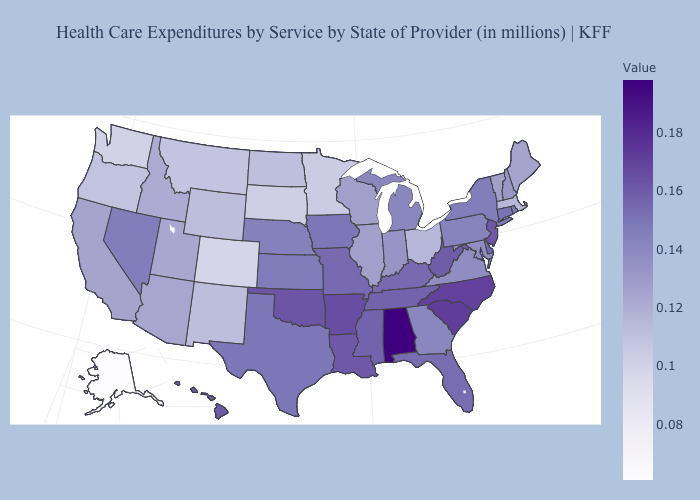Is the legend a continuous bar?
Answer briefly. Yes. Among the states that border Michigan , does Ohio have the lowest value?
Short answer required. Yes. Among the states that border Virginia , does Maryland have the lowest value?
Write a very short answer. Yes. Among the states that border Vermont , does Massachusetts have the highest value?
Give a very brief answer. No. Among the states that border Rhode Island , does Connecticut have the lowest value?
Write a very short answer. No. Does Kentucky have the lowest value in the South?
Answer briefly. No. Among the states that border Washington , does Idaho have the highest value?
Concise answer only. Yes. Does Alabama have the highest value in the USA?
Be succinct. Yes. Which states have the highest value in the USA?
Be succinct. Alabama. 